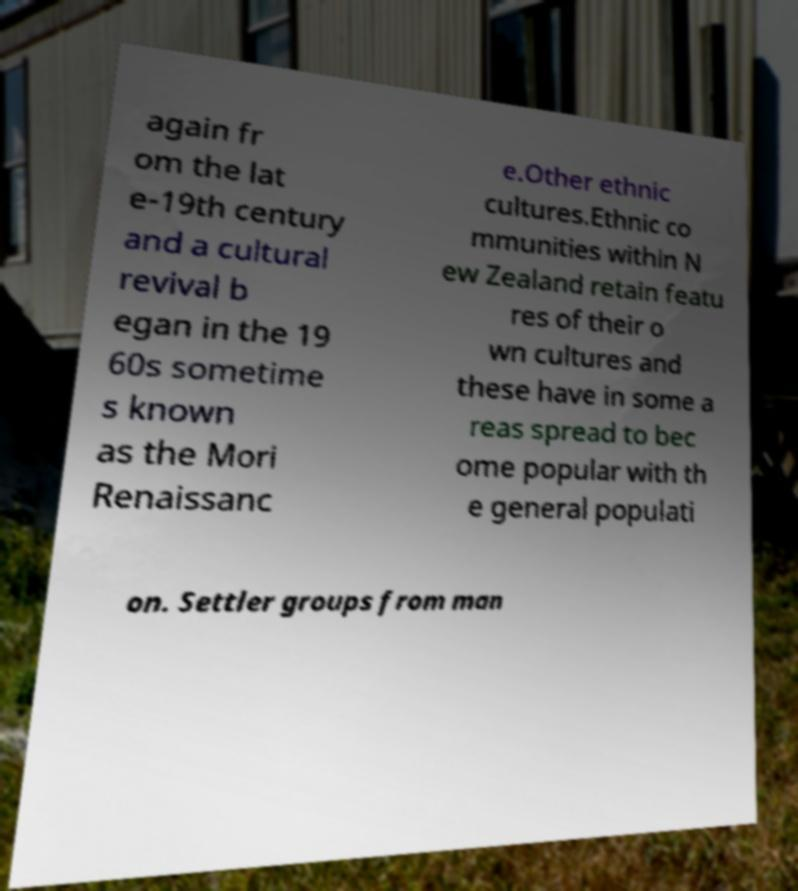Can you accurately transcribe the text from the provided image for me? again fr om the lat e-19th century and a cultural revival b egan in the 19 60s sometime s known as the Mori Renaissanc e.Other ethnic cultures.Ethnic co mmunities within N ew Zealand retain featu res of their o wn cultures and these have in some a reas spread to bec ome popular with th e general populati on. Settler groups from man 